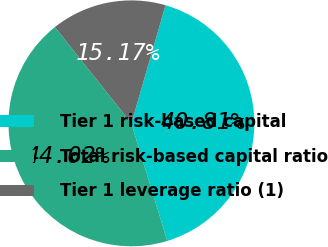Convert chart. <chart><loc_0><loc_0><loc_500><loc_500><pie_chart><fcel>Tier 1 risk-based capital<fcel>Total risk-based capital ratio<fcel>Tier 1 leverage ratio (1)<nl><fcel>40.81%<fcel>44.02%<fcel>15.17%<nl></chart> 